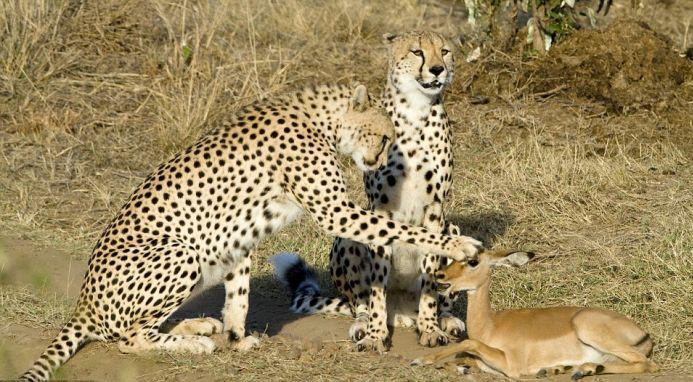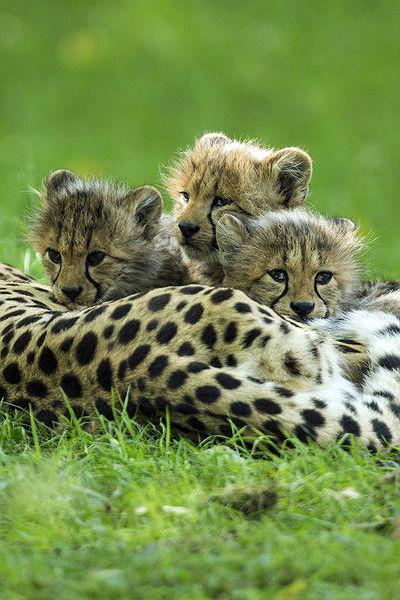The first image is the image on the left, the second image is the image on the right. Considering the images on both sides, is "There are leopards and at least one deer." valid? Answer yes or no. Yes. The first image is the image on the left, the second image is the image on the right. Analyze the images presented: Is the assertion "In one of the images a cheetah can be seen with meat in its mouth." valid? Answer yes or no. No. 